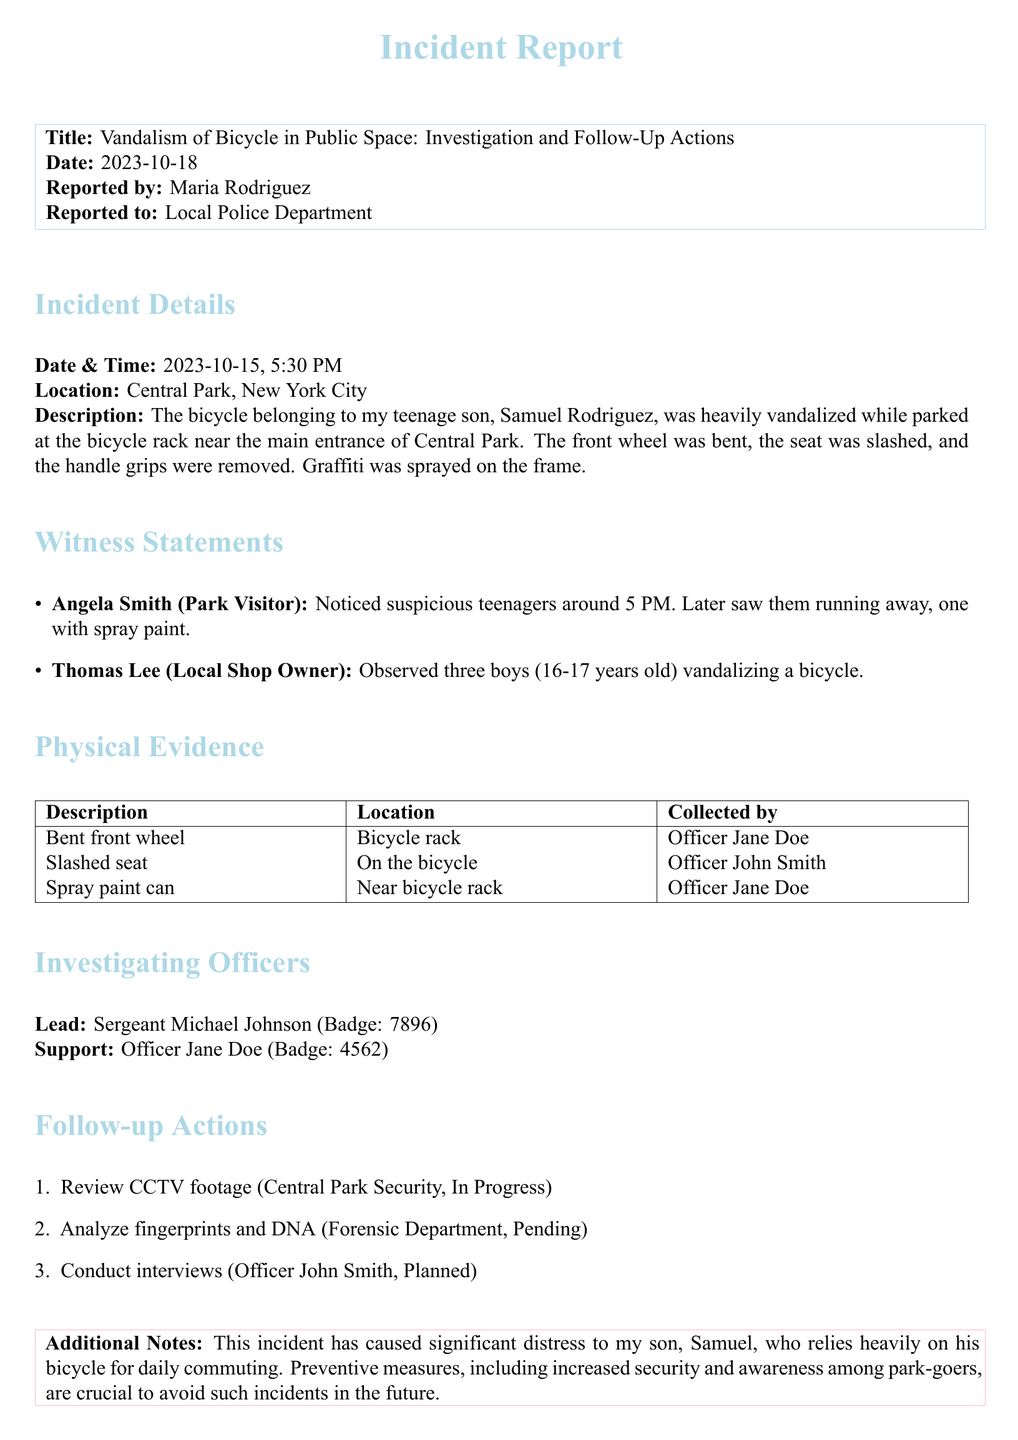What is the date of the incident? The date of the incident is specified in the document as the day the bicycle was vandalized.
Answer: 2023-10-15 Who reported the incident? The report mentions that the incident was reported by the individual's name listed in the document.
Answer: Maria Rodriguez What item was collected by Officer John Smith? The document lists various pieces of physical evidence collected by officers, including what Officer John Smith collected.
Answer: Slashed seat How many witnesses provided statements? The document includes a list of witness statements, allowing for a count of those mentioned.
Answer: Two What was the lead investigating officer's badge number? The badge number for the lead officer is mentioned under investigating officers, which is a critical detail for identification.
Answer: 7896 What is currently pending with the forensic department? The document outlines several follow-up actions, including what is awaiting further investigation by the forensic team.
Answer: Analyze fingerprints and DNA What type of vandalism occurred? The description of the incident details the specific actions that resulted in damage to the bicycle.
Answer: Vandalism What is mentioned as a crucial preventive measure? The report emphasizes the need for measures to avoid a recurrence of the incident, providing insight into the author's concerns.
Answer: Increased security What time did the incident occur? The specific time of the incident can be found in the details, which is important for the timeline of the event.
Answer: 5:30 PM 